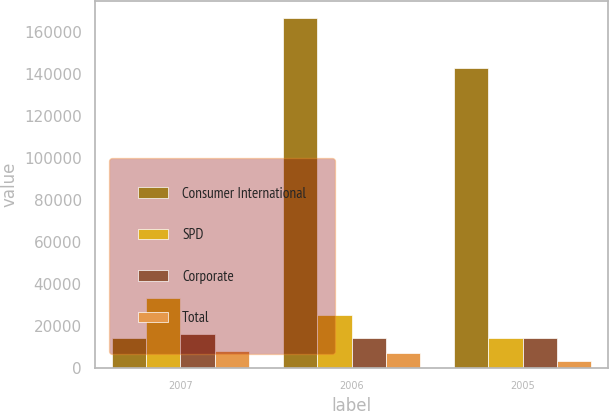Convert chart. <chart><loc_0><loc_0><loc_500><loc_500><stacked_bar_chart><ecel><fcel>2007<fcel>2006<fcel>2005<nl><fcel>Consumer International<fcel>14343<fcel>166490<fcel>142669<nl><fcel>SPD<fcel>33192<fcel>25305<fcel>14322<nl><fcel>Corporate<fcel>16351<fcel>14164<fcel>14343<nl><fcel>Total<fcel>8236<fcel>7135<fcel>3549<nl></chart> 